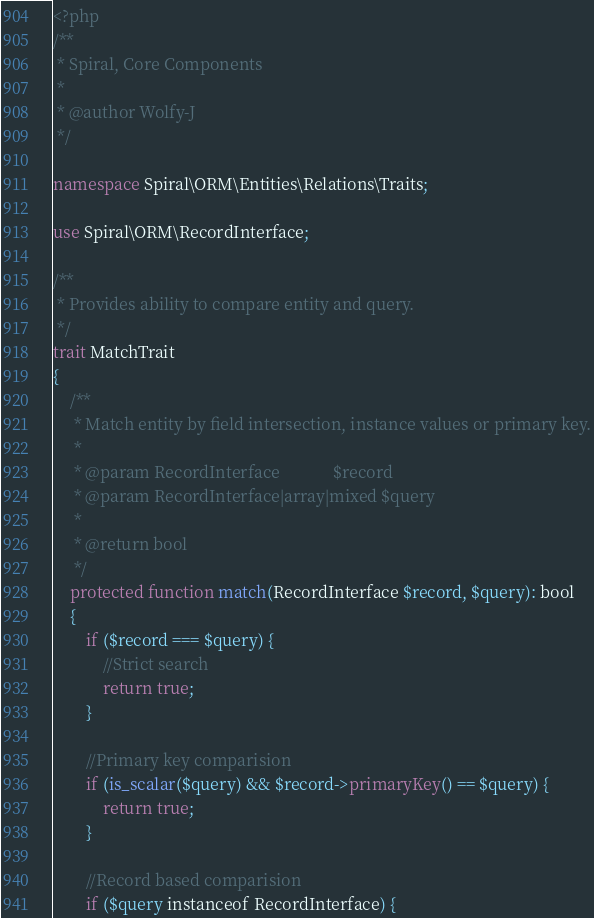Convert code to text. <code><loc_0><loc_0><loc_500><loc_500><_PHP_><?php
/**
 * Spiral, Core Components
 *
 * @author Wolfy-J
 */

namespace Spiral\ORM\Entities\Relations\Traits;

use Spiral\ORM\RecordInterface;

/**
 * Provides ability to compare entity and query.
 */
trait MatchTrait
{
    /**
     * Match entity by field intersection, instance values or primary key.
     *
     * @param RecordInterface             $record
     * @param RecordInterface|array|mixed $query
     *
     * @return bool
     */
    protected function match(RecordInterface $record, $query): bool
    {
        if ($record === $query) {
            //Strict search
            return true;
        }

        //Primary key comparision
        if (is_scalar($query) && $record->primaryKey() == $query) {
            return true;
        }

        //Record based comparision
        if ($query instanceof RecordInterface) {</code> 